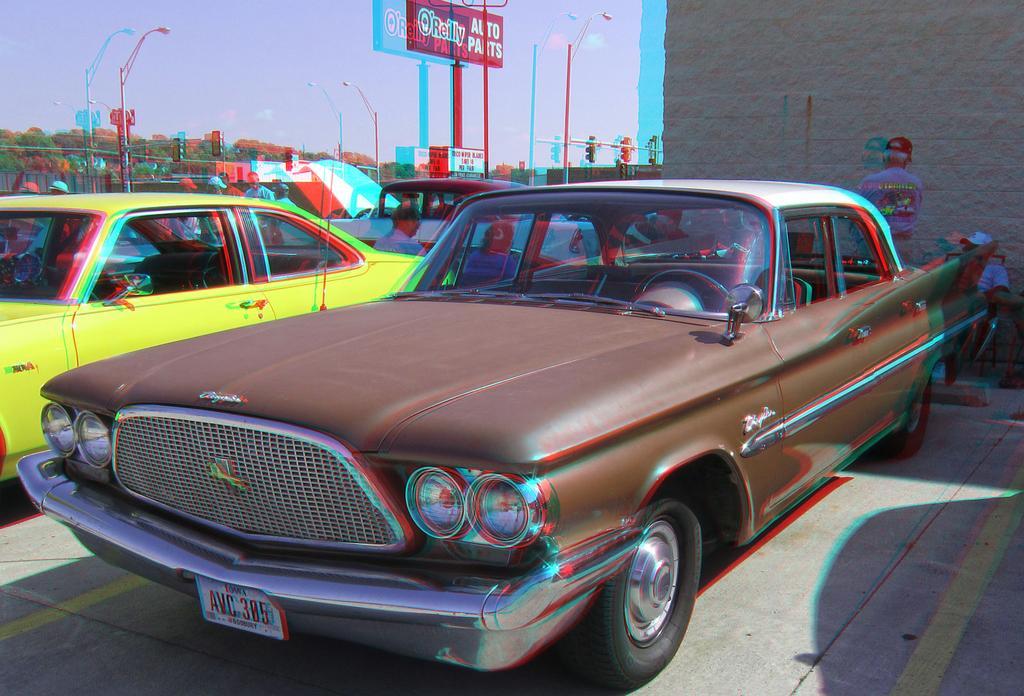How would you summarize this image in a sentence or two? Here we can see a car is parked on the road. Background we can see few vehicles, people. Few people are sitting and standing. Here there is a wall, sky, trees, poles and banners. 